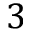<formula> <loc_0><loc_0><loc_500><loc_500>3</formula> 